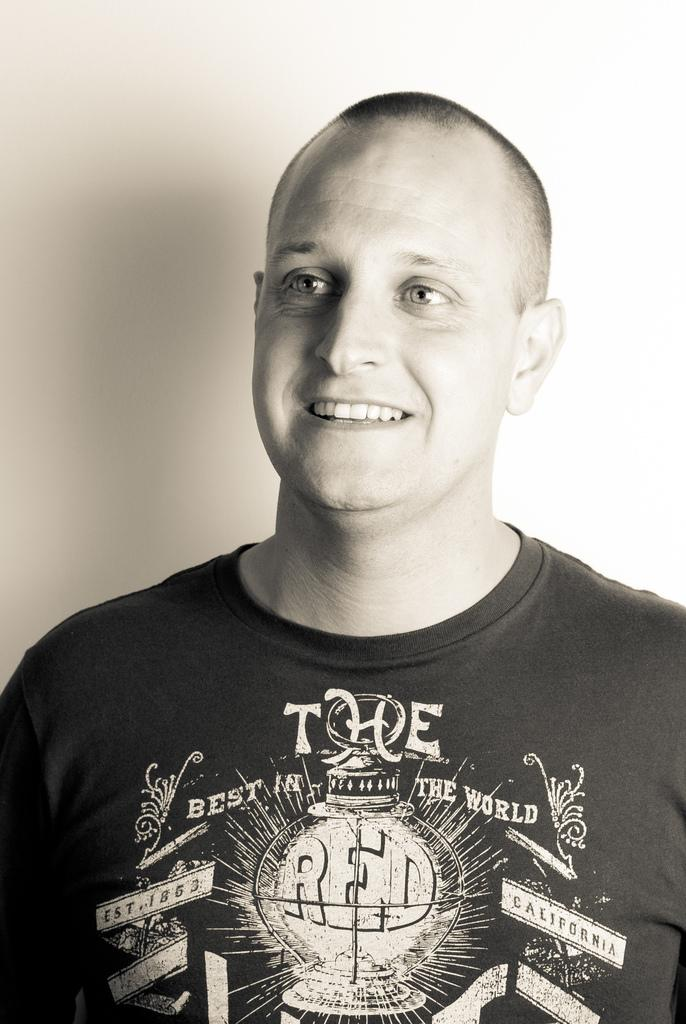What is the main subject of the image? There is a person in the image. What is the person wearing? The person is wearing a T-shirt. What expression does the person have? The person is smiling. What color is the background of the image? The background of the image is white. What type of wine is the person holding in the image? There is no wine present in the image; the person is not holding anything. 